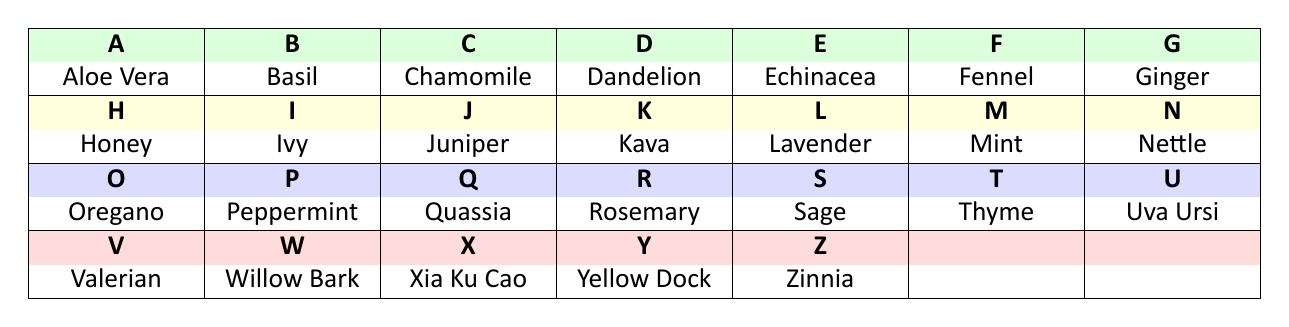What is the historical use of Aloe Vera? Aloe Vera is known for three primary historical uses: wound healing, sunburn relief, and skin hydration. These uses can be found in its entry in the table.
Answer: Wound healing, sunburn relief, skin hydration Which herb originates from the Mediterranean region? By examining the entries in the table, we see several herbs listed as originating from the Mediterranean region, including Fennel, Lavender, Oregano, Rosemary, Sage, and Thyme.
Answer: Fennel, Lavender, Oregano, Rosemary, Sage, Thyme Does Ginger have any historical uses related to nausea? In the table, Ginger is noted for its historical use in nausea relief, indicating that this fact is true.
Answer: Yes What are the historical uses of Valerian? Valerian has three historical uses as mentioned in the table, which are sleep aid, anxiety relief, and calming agent.
Answer: Sleep aid, anxiety relief, calming agent How many herbs have historical uses related to digestive health? Looking at the entries in the table, Dandelion, Fennel, Mint, Oregano, Peppermint, Quassia, Rosemary, and Sage are all noted for their historical uses relating to digestive health; that's a total of eight herbs.
Answer: 8 Is Honey associated with wound healing? Checking the table, Honey is listed as having wound healing as one of its historical uses, confirming this fact as true.
Answer: Yes Which herb has the most historical uses in the table? Upon reviewing the table, most herbs have three historical uses listed. However, Ginger and others also emphasize general culinary uses, but no herb has more than three distinct uses mentioned. Thus, they can be viewed equally.
Answer: All have three uses What is the average number of historical uses for the herbs listed? Each herb in the table has three historical uses listed. Since all 26 herbs have the same number, the average is simply three.
Answer: 3 Which herb is known for both urinary health and anti-inflammatory uses? In the table, Uva Ursi is listed with historical uses that include urinary health and anti-inflammatory properties.
Answer: Uva Ursi 